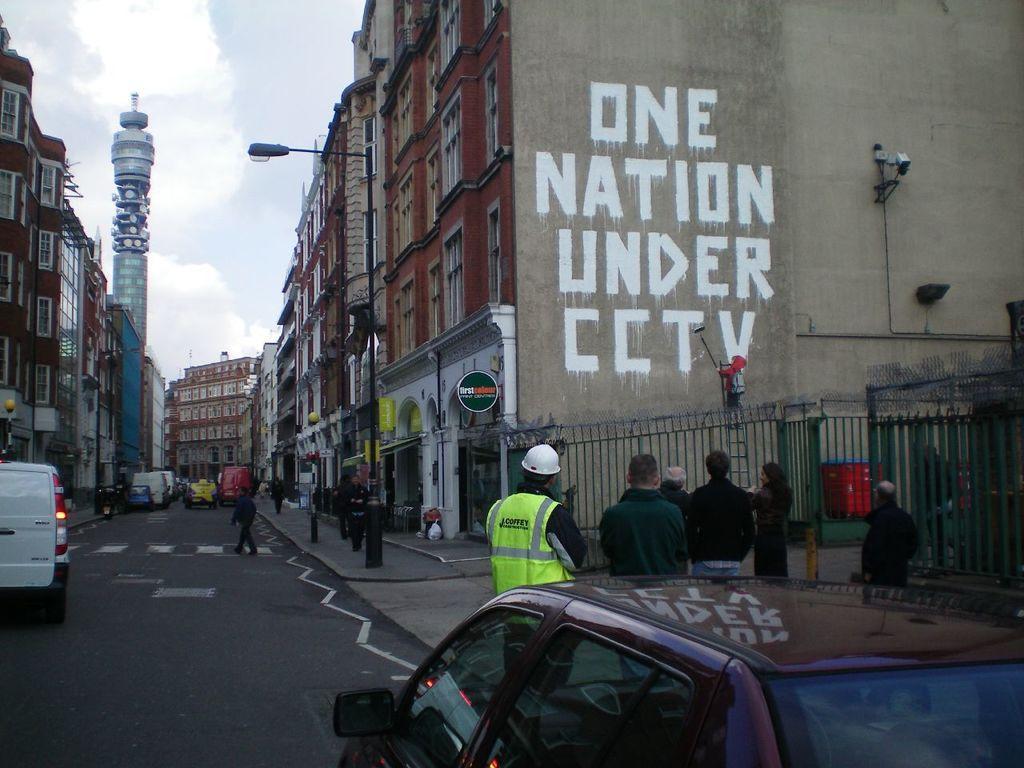Please provide a concise description of this image. In this picture, we can see a few people, vehicles, buildings with windows, poles, lights, fencing, and we can see a some text and some objects attached to the wall, we can see the road, the sky with clouds. 